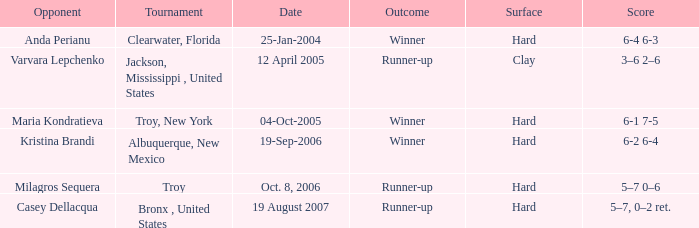What was the surface of the game that resulted in a final score of 6-1 7-5? Hard. 